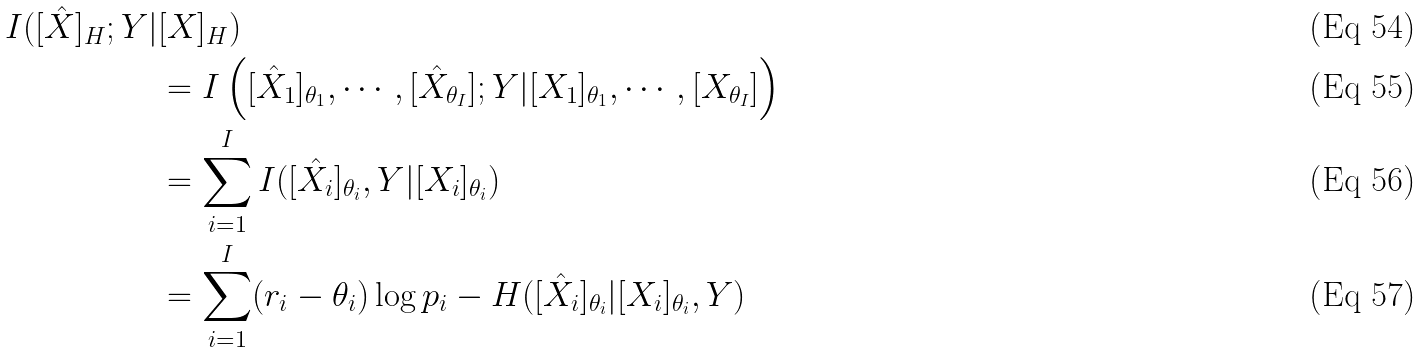<formula> <loc_0><loc_0><loc_500><loc_500>I ( [ \hat { X } ] _ { H } ; Y | & [ X ] _ { H } ) \\ & = I \left ( [ \hat { X } _ { 1 } ] _ { \theta _ { 1 } } , \cdots , [ \hat { X } _ { \theta _ { I } } ] ; Y | [ { X } _ { 1 } ] _ { \theta _ { 1 } } , \cdots , [ { X } _ { \theta _ { I } } ] \right ) \\ & = \sum _ { i = 1 } ^ { I } I ( [ \hat { X } _ { i } ] _ { \theta _ { i } } , Y | [ { X } _ { i } ] _ { \theta _ { i } } ) \\ & = \sum _ { i = 1 } ^ { I } ( r _ { i } - \theta _ { i } ) \log p _ { i } - H ( [ \hat { X } _ { i } ] _ { \theta _ { i } } | [ X _ { i } ] _ { \theta _ { i } } , Y )</formula> 